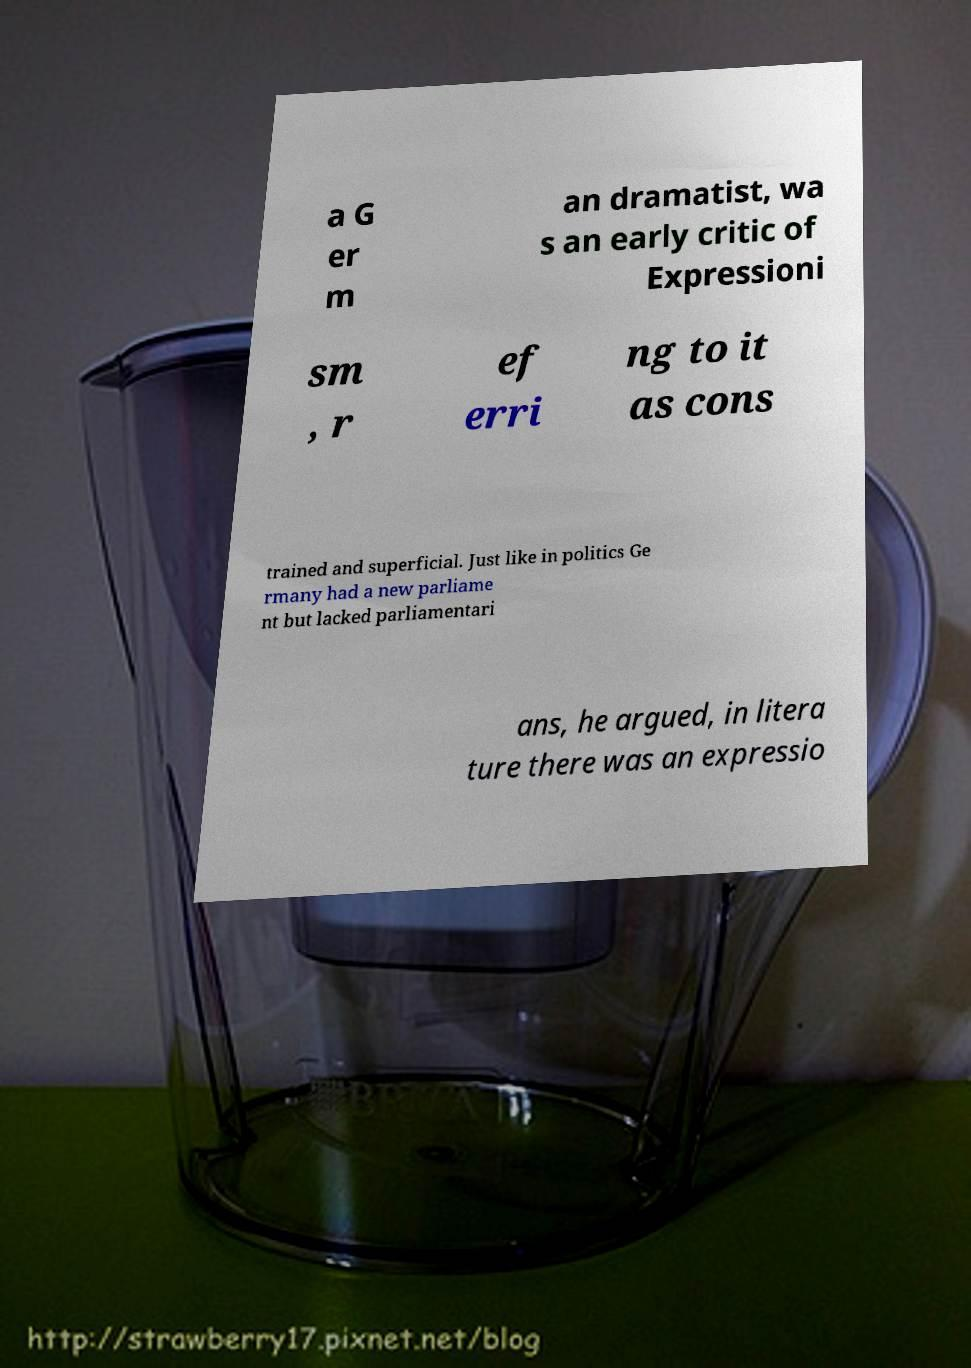Can you accurately transcribe the text from the provided image for me? a G er m an dramatist, wa s an early critic of Expressioni sm , r ef erri ng to it as cons trained and superficial. Just like in politics Ge rmany had a new parliame nt but lacked parliamentari ans, he argued, in litera ture there was an expressio 